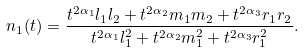Convert formula to latex. <formula><loc_0><loc_0><loc_500><loc_500>n _ { 1 } ( t ) = \frac { t ^ { 2 \alpha _ { 1 } } l _ { 1 } l _ { 2 } + t ^ { 2 \alpha _ { 2 } } m _ { 1 } m _ { 2 } + t ^ { 2 \alpha _ { 3 } } r _ { 1 } r _ { 2 } } { t ^ { 2 \alpha _ { 1 } } l _ { 1 } ^ { 2 } + t ^ { 2 \alpha _ { 2 } } m _ { 1 } ^ { 2 } + t ^ { 2 \alpha _ { 3 } } r _ { 1 } ^ { 2 } } .</formula> 